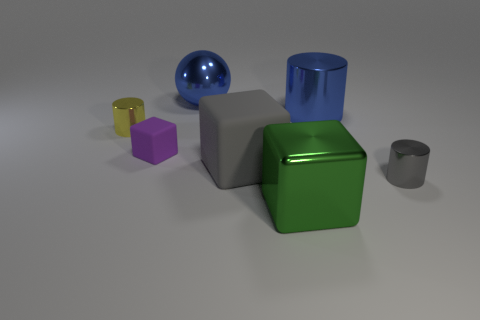What is the shape of the green shiny object that is in front of the small rubber block?
Offer a terse response. Cube. What number of metallic cubes are the same size as the yellow metallic thing?
Your response must be concise. 0. There is a shiny cylinder that is in front of the big matte object; does it have the same color as the big cylinder?
Give a very brief answer. No. There is a cube that is both to the right of the shiny sphere and behind the gray metal object; what is it made of?
Give a very brief answer. Rubber. Are there more tiny gray metallic cylinders than rubber things?
Your answer should be compact. No. What is the color of the shiny cylinder behind the small metal object that is on the left side of the gray rubber object to the right of the tiny purple block?
Your answer should be very brief. Blue. Are the tiny cylinder to the left of the ball and the small purple object made of the same material?
Offer a very short reply. No. Are there any shiny objects that have the same color as the shiny sphere?
Ensure brevity in your answer.  Yes. Are any tiny shiny objects visible?
Make the answer very short. Yes. There is a cylinder that is to the left of the purple rubber object; does it have the same size as the purple rubber thing?
Give a very brief answer. Yes. 